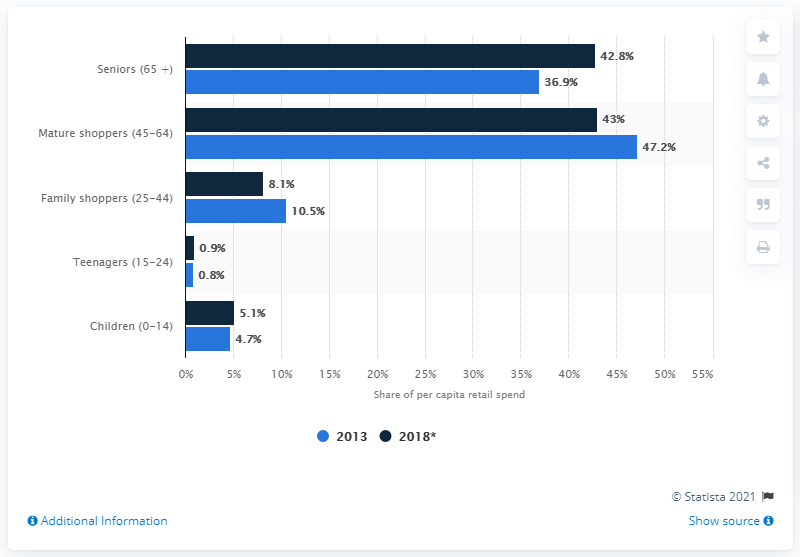Indicate a few pertinent items in this graphic. In the year 2013, the age distribution of retail spending per capita in Germany was as follows: According to the data provided, the sum of the per capita of children and teenagers in 2018 is 6. 